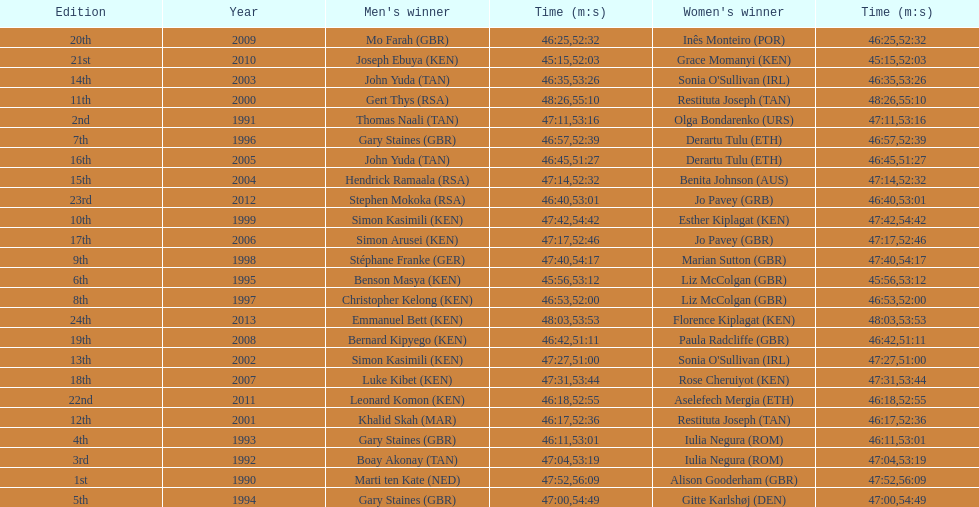Who is the male champion listed prior to gert thys? Simon Kasimili. 